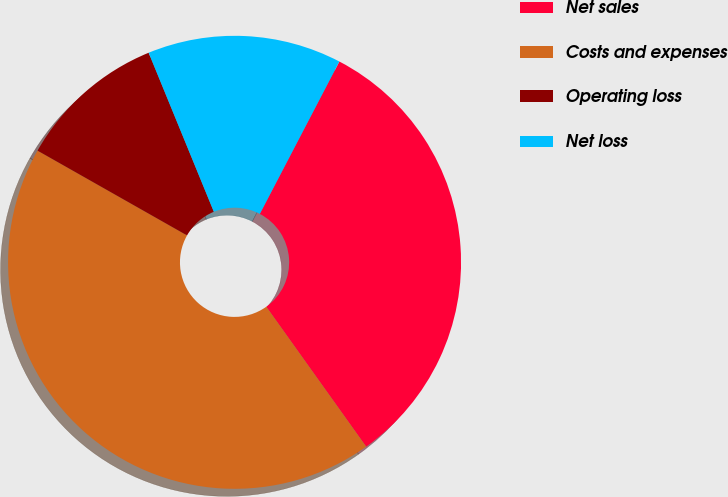Convert chart to OTSL. <chart><loc_0><loc_0><loc_500><loc_500><pie_chart><fcel>Net sales<fcel>Costs and expenses<fcel>Operating loss<fcel>Net loss<nl><fcel>32.48%<fcel>43.08%<fcel>10.6%<fcel>13.85%<nl></chart> 